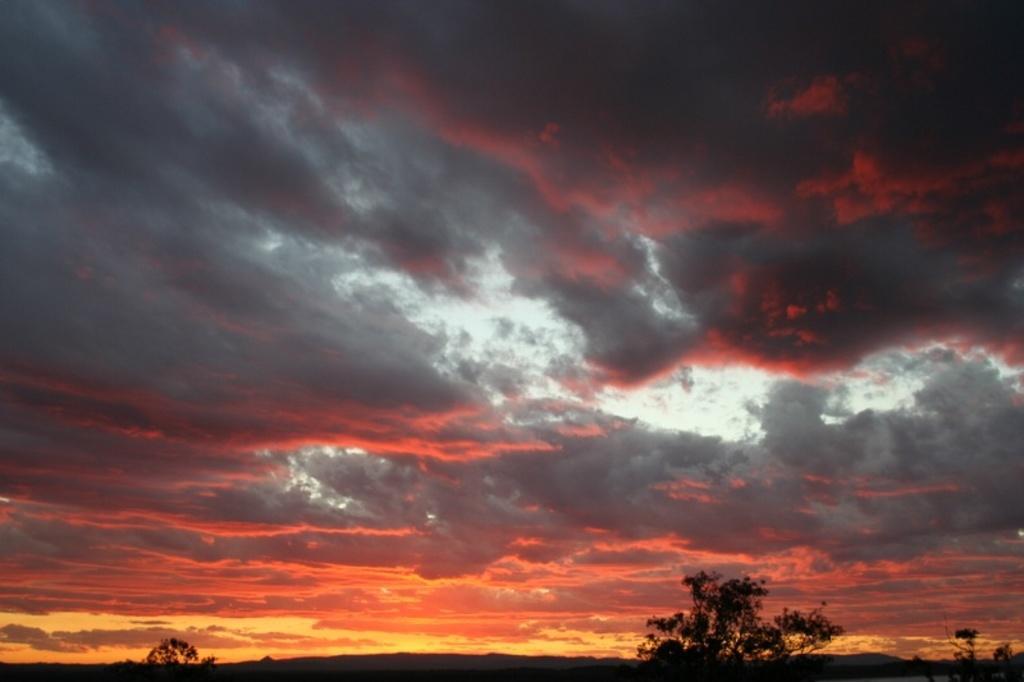Please provide a concise description of this image. In this image there are trees at the bottom. At the top there is a sky which is in orange colour. 